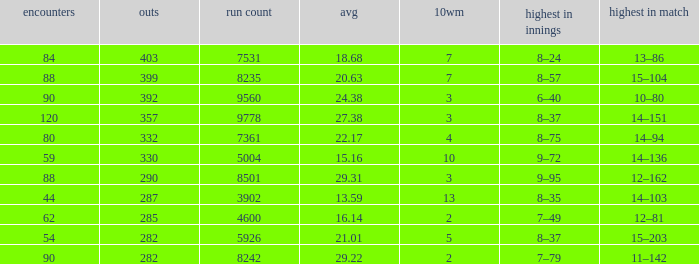What is the sum of runs that are associated with 10WM values over 13? None. 